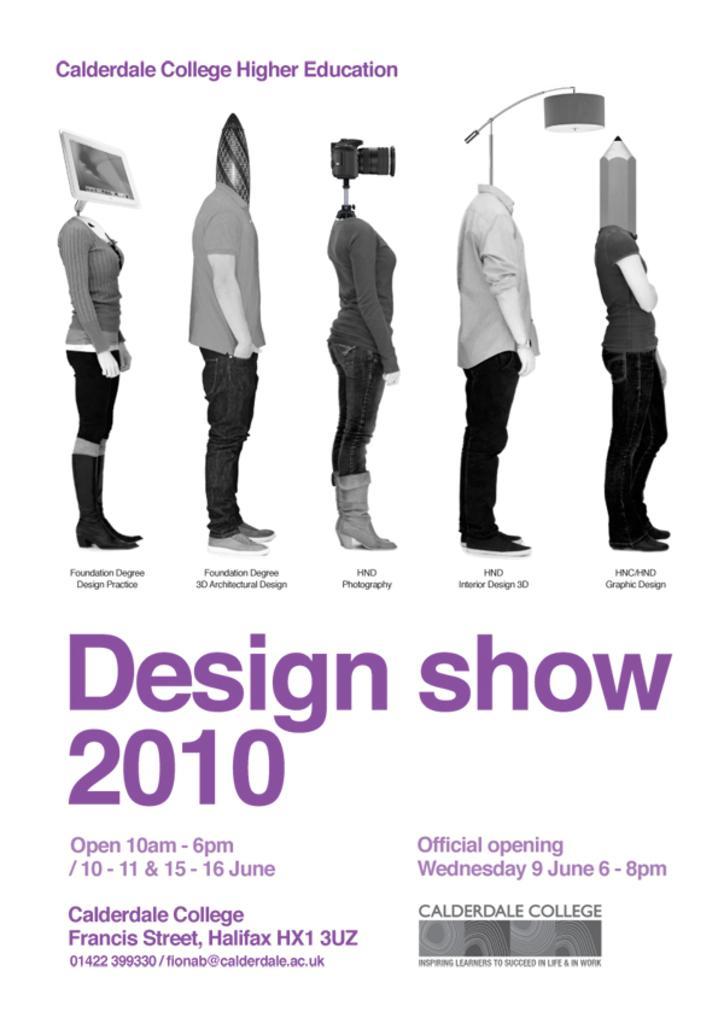In one or two sentences, can you explain what this image depicts? In this image there are some pictures of some persons in the middle of this image. There is some text written in the bottom of this image and on the top of this image as well. 